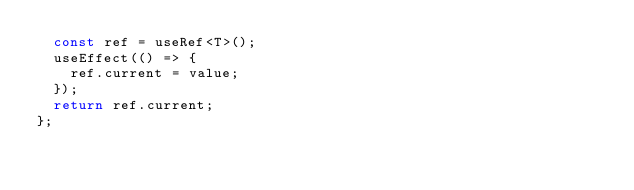Convert code to text. <code><loc_0><loc_0><loc_500><loc_500><_TypeScript_>	const ref = useRef<T>();
	useEffect(() => {
		ref.current = value;
	});
	return ref.current;
};
</code> 